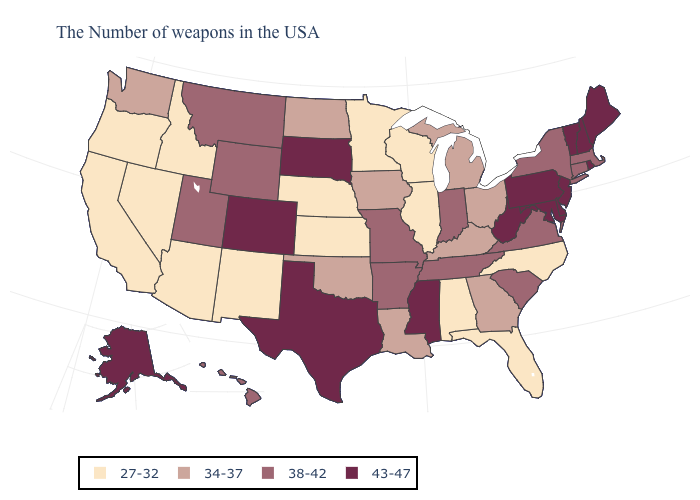Which states have the highest value in the USA?
Give a very brief answer. Maine, Rhode Island, New Hampshire, Vermont, New Jersey, Delaware, Maryland, Pennsylvania, West Virginia, Mississippi, Texas, South Dakota, Colorado, Alaska. Which states hav the highest value in the MidWest?
Quick response, please. South Dakota. What is the value of Texas?
Short answer required. 43-47. Which states hav the highest value in the South?
Give a very brief answer. Delaware, Maryland, West Virginia, Mississippi, Texas. Does Florida have the highest value in the South?
Write a very short answer. No. What is the value of Tennessee?
Write a very short answer. 38-42. Among the states that border South Carolina , which have the lowest value?
Write a very short answer. North Carolina. What is the lowest value in the Northeast?
Answer briefly. 38-42. Name the states that have a value in the range 27-32?
Give a very brief answer. North Carolina, Florida, Alabama, Wisconsin, Illinois, Minnesota, Kansas, Nebraska, New Mexico, Arizona, Idaho, Nevada, California, Oregon. Does the first symbol in the legend represent the smallest category?
Answer briefly. Yes. What is the value of Virginia?
Short answer required. 38-42. Does Colorado have the same value as Mississippi?
Give a very brief answer. Yes. Name the states that have a value in the range 27-32?
Be succinct. North Carolina, Florida, Alabama, Wisconsin, Illinois, Minnesota, Kansas, Nebraska, New Mexico, Arizona, Idaho, Nevada, California, Oregon. What is the value of Minnesota?
Write a very short answer. 27-32. What is the value of Hawaii?
Concise answer only. 38-42. 